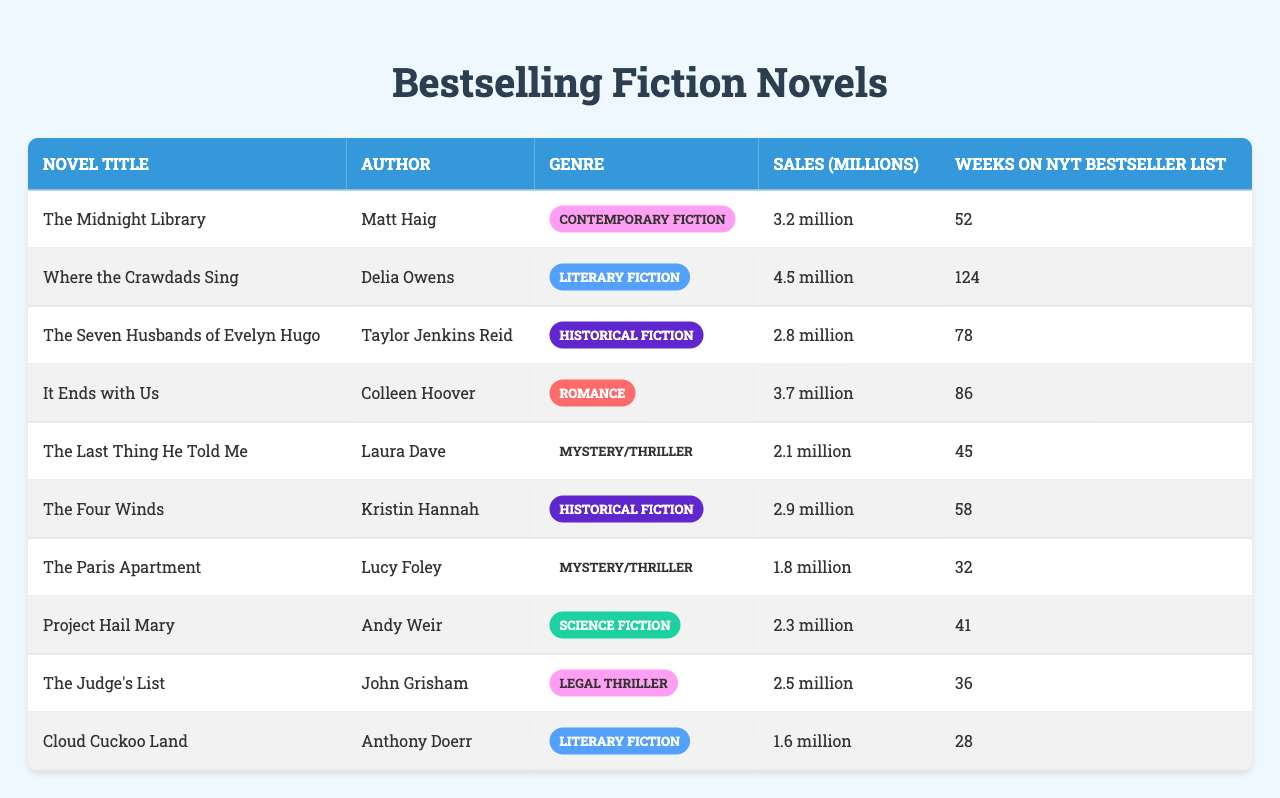What is the bestselling novel in terms of sales? "Where the Crawdads Sing" has the highest sales figure at 4.5 million.
Answer: Where the Crawdads Sing How many weeks did "The Midnight Library" stay on the bestseller list? "The Midnight Library" stayed on the bestseller list for 52 weeks.
Answer: 52 weeks What is the total sales figure for the novels in the "Historical Fiction" genre? The total sales for the "Historical Fiction" novels are (2.8 + 2.9) = 5.7 million.
Answer: 5.7 million Is "The Paris Apartment" the least sold novel in the table? Yes, "The Paris Apartment" has the lowest sales figure at 1.8 million.
Answer: Yes What is the average sales figure of the novels in the "Mystery/Thriller" genre? The sales figures for "The Last Thing He Told Me" and "The Paris Apartment" are 2.1 and 1.8 million respectively, the average is (2.1 + 1.8) / 2 = 1.95 million.
Answer: 1.95 million How many novels had sales greater than 3 million? "Where the Crawdads Sing" (4.5), "It Ends with Us" (3.7), and "The Midnight Library" (3.2) had sales greater than 3 million, totaling 3 novels.
Answer: 3 novels What is the difference in sales between the bestselling novel and the least sold novel? The difference is 4.5 (bestselling) - 1.8 (least sold) = 2.7 million.
Answer: 2.7 million Which novel spent the most weeks on the NYT Bestseller List? "Where the Crawdads Sing" spent the most weeks on the list with 124 weeks.
Answer: 124 weeks What genre does "Cloud Cuckoo Land" belong to? "Cloud Cuckoo Land" is categorized under "Literary Fiction."
Answer: Literary Fiction How many novels on the bestseller list are authored by female writers? There are 5 novels authored by female writers: "Where the Crawdads Sing," "It Ends with Us," "The Four Winds," "The Paris Apartment," and "The Last Thing He Told Me."
Answer: 5 novels 